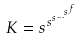<formula> <loc_0><loc_0><loc_500><loc_500>K = s ^ { s ^ { s ^ { \dots ^ { s ^ { f } } } } }</formula> 